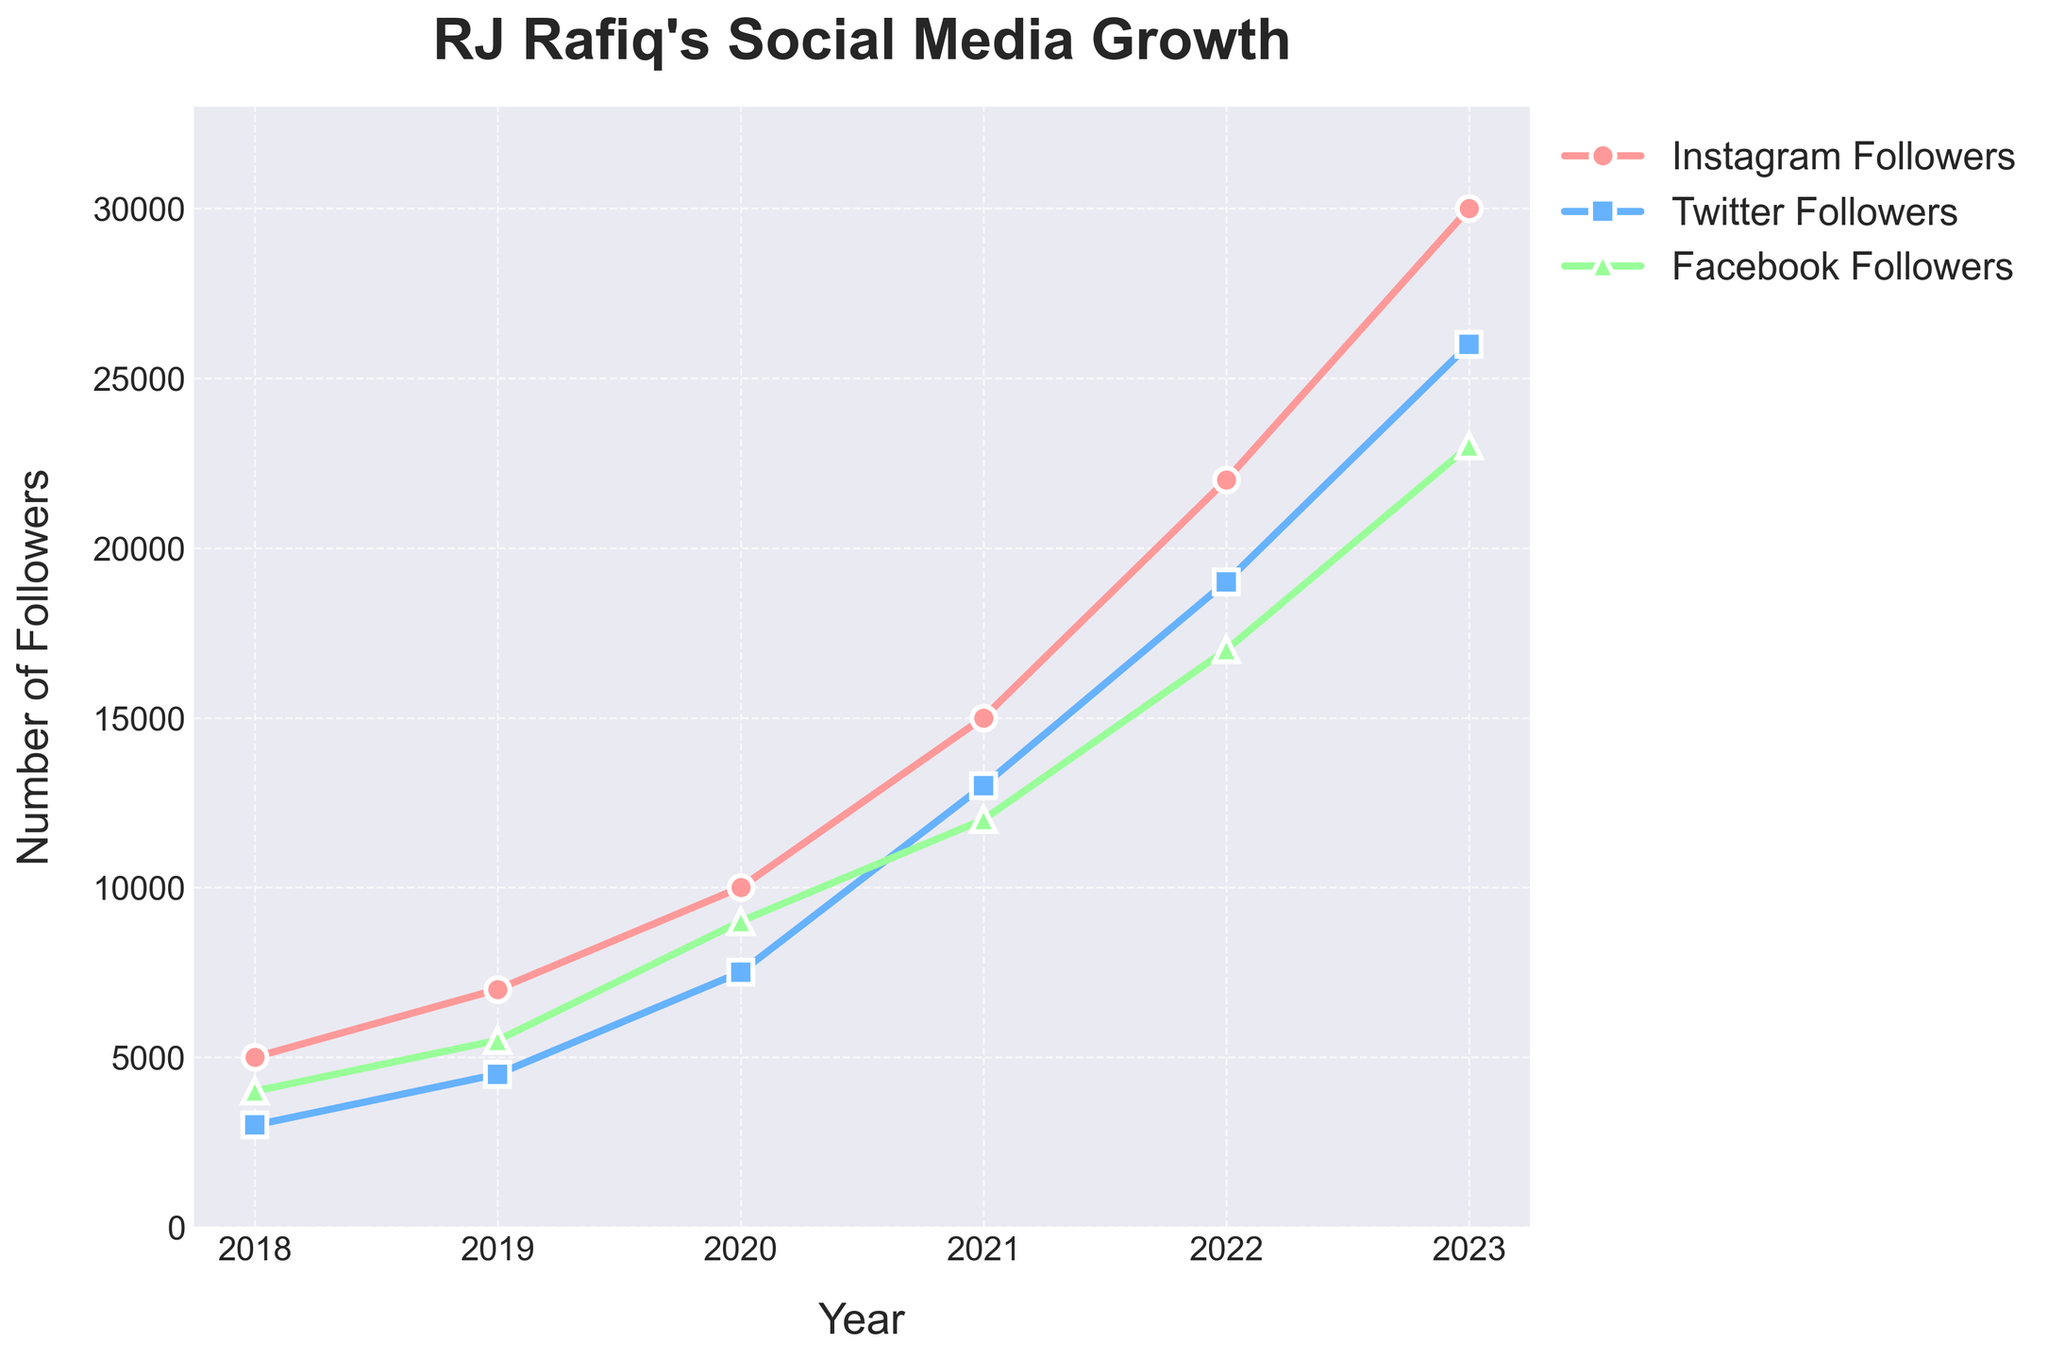What is the title of the plot? The title is positioned at the top of the plot and usually provides a clear indication of what the plot represents. In this case, the title is “RJ Rafiq's Social Media Growth.”
Answer: RJ Rafiq's Social Media Growth Which social media platform had the highest number of followers in 2022? By looking at the plot, we can compare the values for 2022 for each platform. Instagram had the highest number of followers in 2022.
Answer: Instagram In which year did Twitter followers see the highest increase compared to the previous year? By analyzing the slopes between consecutive years for Twitter followers, the largest increase occurred between 2020 and 2021.
Answer: 2021 What is the difference in Instagram followers between 2021 and 2023? In 2021, there were 15,000 Instagram followers, and in 2023, there were 30,000. The difference is 30,000 - 15,000.
Answer: 15,000 Which year had the smallest number of Facebook followers, and how many were there? The smallest number of Facebook followers is in 2018, as it's the starting year of the data. The count is 4,000.
Answer: 2018, 4,000 Between which consecutive years did Instagram followers grow by 5,000? By checking the changes, we see that Instagram followers grow from 10,000 in 2020 to 15,000 in 2021.
Answer: Between 2020 and 2021 How many followers did RJ Rafiq gain on Twitter between 2019 and 2023? The number of Twitter followers in 2019 is 4,500 and in 2023 is 26,000. The gain is 26,000 - 4,500.
Answer: 21,500 Which platform showed the highest growth rate (in terms of followers gained) over the entire period from 2018 to 2023? By comparing the total increase from 2018 to 2023 for each platform, Instagram had the highest growth, going from 5,000 to 30,000, which is an increase of 25,000 followers.
Answer: Instagram What was the average number of Instagram followers over the six years from 2018 to 2023? Sum up all the yearly Instagram followers (5,000 + 7,000 + 10,000 + 15,000 + 22,000 + 30,000) and then divide by 6. The average is (5,000 + 7,000 + 10,000 + 15,000 + 22,000 + 30,000) / 6.
Answer: 14,833 In which year did RJ Rafiq have the highest combined total of followers across all three platforms, and what was the total? Calculate the sum of followers for each year. 2023 has the highest total: 30,000 (Instagram) + 26,000 (Twitter) + 23,000 (Facebook) = 79,000.
Answer: 2023, 79,000 